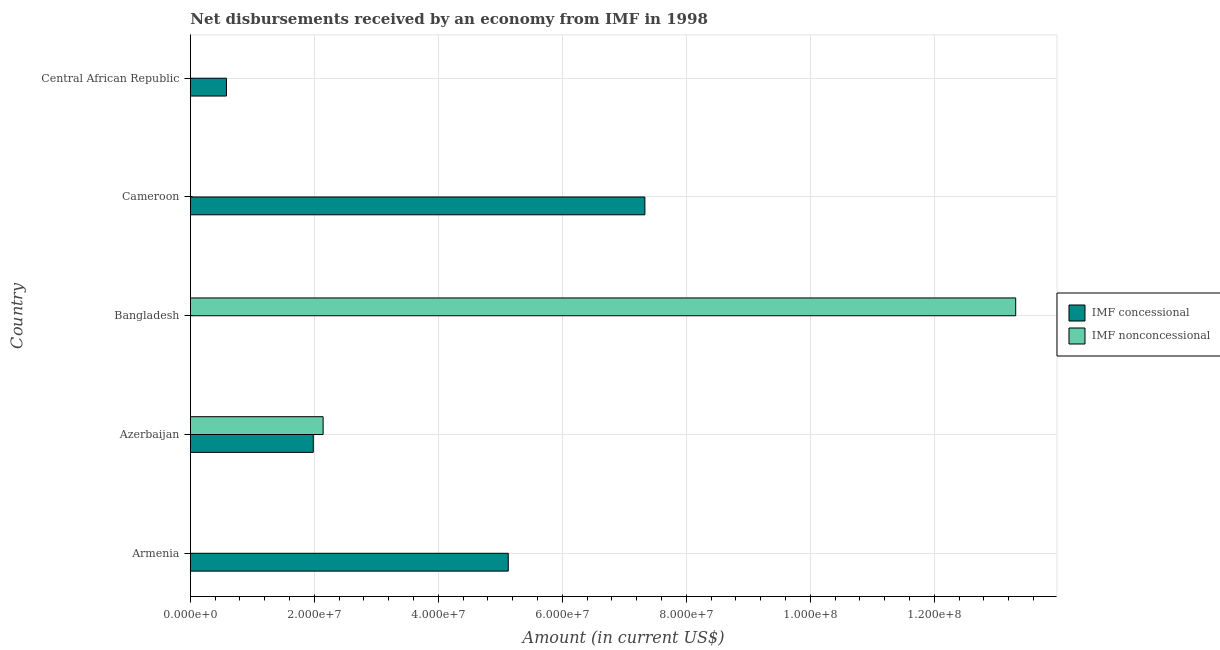How many different coloured bars are there?
Provide a short and direct response. 2. Are the number of bars per tick equal to the number of legend labels?
Make the answer very short. No. How many bars are there on the 4th tick from the top?
Provide a short and direct response. 2. How many bars are there on the 4th tick from the bottom?
Your answer should be compact. 1. What is the label of the 2nd group of bars from the top?
Make the answer very short. Cameroon. In how many cases, is the number of bars for a given country not equal to the number of legend labels?
Keep it short and to the point. 4. What is the net non concessional disbursements from imf in Central African Republic?
Offer a terse response. 0. Across all countries, what is the maximum net concessional disbursements from imf?
Your answer should be compact. 7.33e+07. In which country was the net concessional disbursements from imf maximum?
Offer a very short reply. Cameroon. What is the total net concessional disbursements from imf in the graph?
Provide a short and direct response. 1.50e+08. What is the difference between the net non concessional disbursements from imf in Azerbaijan and that in Bangladesh?
Ensure brevity in your answer.  -1.12e+08. What is the difference between the net concessional disbursements from imf in Bangladesh and the net non concessional disbursements from imf in Azerbaijan?
Offer a terse response. -2.14e+07. What is the average net non concessional disbursements from imf per country?
Ensure brevity in your answer.  3.09e+07. What is the difference between the net concessional disbursements from imf and net non concessional disbursements from imf in Azerbaijan?
Offer a very short reply. -1.59e+06. What is the ratio of the net concessional disbursements from imf in Azerbaijan to that in Central African Republic?
Your answer should be compact. 3.4. Is the net non concessional disbursements from imf in Azerbaijan less than that in Bangladesh?
Make the answer very short. Yes. What is the difference between the highest and the second highest net concessional disbursements from imf?
Make the answer very short. 2.20e+07. What is the difference between the highest and the lowest net concessional disbursements from imf?
Your response must be concise. 7.33e+07. In how many countries, is the net concessional disbursements from imf greater than the average net concessional disbursements from imf taken over all countries?
Offer a terse response. 2. Is the sum of the net non concessional disbursements from imf in Azerbaijan and Bangladesh greater than the maximum net concessional disbursements from imf across all countries?
Provide a short and direct response. Yes. How many bars are there?
Provide a short and direct response. 6. How many countries are there in the graph?
Provide a succinct answer. 5. What is the difference between two consecutive major ticks on the X-axis?
Make the answer very short. 2.00e+07. Does the graph contain any zero values?
Provide a short and direct response. Yes. Does the graph contain grids?
Provide a short and direct response. Yes. How many legend labels are there?
Provide a short and direct response. 2. What is the title of the graph?
Give a very brief answer. Net disbursements received by an economy from IMF in 1998. What is the label or title of the X-axis?
Your answer should be compact. Amount (in current US$). What is the Amount (in current US$) of IMF concessional in Armenia?
Your answer should be very brief. 5.13e+07. What is the Amount (in current US$) of IMF nonconcessional in Armenia?
Give a very brief answer. 0. What is the Amount (in current US$) of IMF concessional in Azerbaijan?
Your response must be concise. 1.98e+07. What is the Amount (in current US$) in IMF nonconcessional in Azerbaijan?
Offer a very short reply. 2.14e+07. What is the Amount (in current US$) of IMF concessional in Bangladesh?
Offer a very short reply. 0. What is the Amount (in current US$) in IMF nonconcessional in Bangladesh?
Make the answer very short. 1.33e+08. What is the Amount (in current US$) of IMF concessional in Cameroon?
Your answer should be compact. 7.33e+07. What is the Amount (in current US$) in IMF nonconcessional in Cameroon?
Offer a very short reply. 0. What is the Amount (in current US$) in IMF concessional in Central African Republic?
Offer a very short reply. 5.83e+06. What is the Amount (in current US$) of IMF nonconcessional in Central African Republic?
Your response must be concise. 0. Across all countries, what is the maximum Amount (in current US$) of IMF concessional?
Your answer should be compact. 7.33e+07. Across all countries, what is the maximum Amount (in current US$) of IMF nonconcessional?
Offer a terse response. 1.33e+08. Across all countries, what is the minimum Amount (in current US$) of IMF concessional?
Your answer should be very brief. 0. What is the total Amount (in current US$) in IMF concessional in the graph?
Offer a very short reply. 1.50e+08. What is the total Amount (in current US$) of IMF nonconcessional in the graph?
Provide a short and direct response. 1.55e+08. What is the difference between the Amount (in current US$) in IMF concessional in Armenia and that in Azerbaijan?
Provide a succinct answer. 3.14e+07. What is the difference between the Amount (in current US$) in IMF concessional in Armenia and that in Cameroon?
Offer a very short reply. -2.20e+07. What is the difference between the Amount (in current US$) in IMF concessional in Armenia and that in Central African Republic?
Your answer should be very brief. 4.55e+07. What is the difference between the Amount (in current US$) in IMF nonconcessional in Azerbaijan and that in Bangladesh?
Keep it short and to the point. -1.12e+08. What is the difference between the Amount (in current US$) of IMF concessional in Azerbaijan and that in Cameroon?
Your answer should be very brief. -5.35e+07. What is the difference between the Amount (in current US$) of IMF concessional in Azerbaijan and that in Central African Republic?
Keep it short and to the point. 1.40e+07. What is the difference between the Amount (in current US$) of IMF concessional in Cameroon and that in Central African Republic?
Your answer should be compact. 6.75e+07. What is the difference between the Amount (in current US$) of IMF concessional in Armenia and the Amount (in current US$) of IMF nonconcessional in Azerbaijan?
Give a very brief answer. 2.99e+07. What is the difference between the Amount (in current US$) of IMF concessional in Armenia and the Amount (in current US$) of IMF nonconcessional in Bangladesh?
Provide a short and direct response. -8.18e+07. What is the difference between the Amount (in current US$) of IMF concessional in Azerbaijan and the Amount (in current US$) of IMF nonconcessional in Bangladesh?
Your answer should be compact. -1.13e+08. What is the average Amount (in current US$) in IMF concessional per country?
Offer a terse response. 3.01e+07. What is the average Amount (in current US$) of IMF nonconcessional per country?
Offer a terse response. 3.09e+07. What is the difference between the Amount (in current US$) in IMF concessional and Amount (in current US$) in IMF nonconcessional in Azerbaijan?
Offer a terse response. -1.59e+06. What is the ratio of the Amount (in current US$) in IMF concessional in Armenia to that in Azerbaijan?
Make the answer very short. 2.59. What is the ratio of the Amount (in current US$) of IMF concessional in Armenia to that in Cameroon?
Give a very brief answer. 0.7. What is the ratio of the Amount (in current US$) of IMF concessional in Armenia to that in Central African Republic?
Give a very brief answer. 8.79. What is the ratio of the Amount (in current US$) in IMF nonconcessional in Azerbaijan to that in Bangladesh?
Offer a very short reply. 0.16. What is the ratio of the Amount (in current US$) of IMF concessional in Azerbaijan to that in Cameroon?
Offer a terse response. 0.27. What is the ratio of the Amount (in current US$) of IMF concessional in Azerbaijan to that in Central African Republic?
Offer a terse response. 3.4. What is the ratio of the Amount (in current US$) of IMF concessional in Cameroon to that in Central African Republic?
Ensure brevity in your answer.  12.57. What is the difference between the highest and the second highest Amount (in current US$) in IMF concessional?
Your answer should be very brief. 2.20e+07. What is the difference between the highest and the lowest Amount (in current US$) in IMF concessional?
Offer a very short reply. 7.33e+07. What is the difference between the highest and the lowest Amount (in current US$) of IMF nonconcessional?
Offer a terse response. 1.33e+08. 